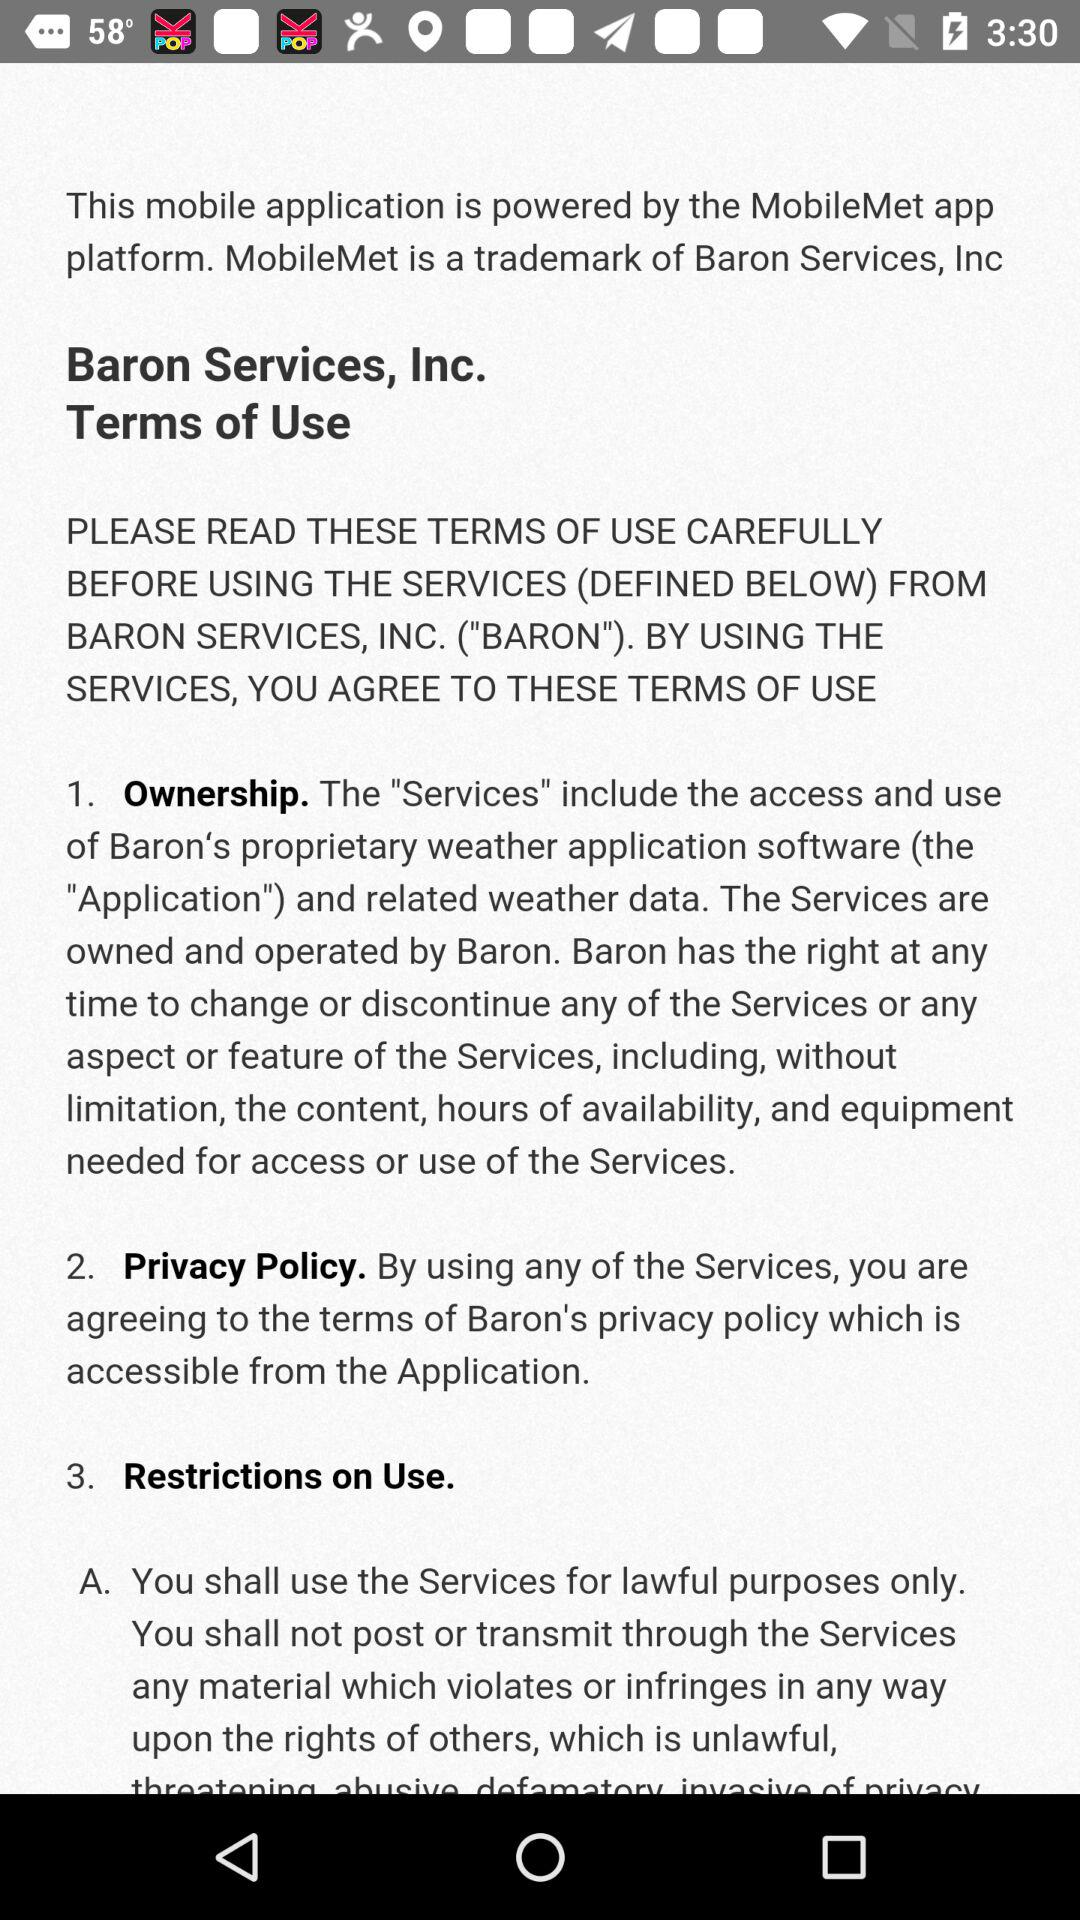How many terms of use sections are there?
Answer the question using a single word or phrase. 3 